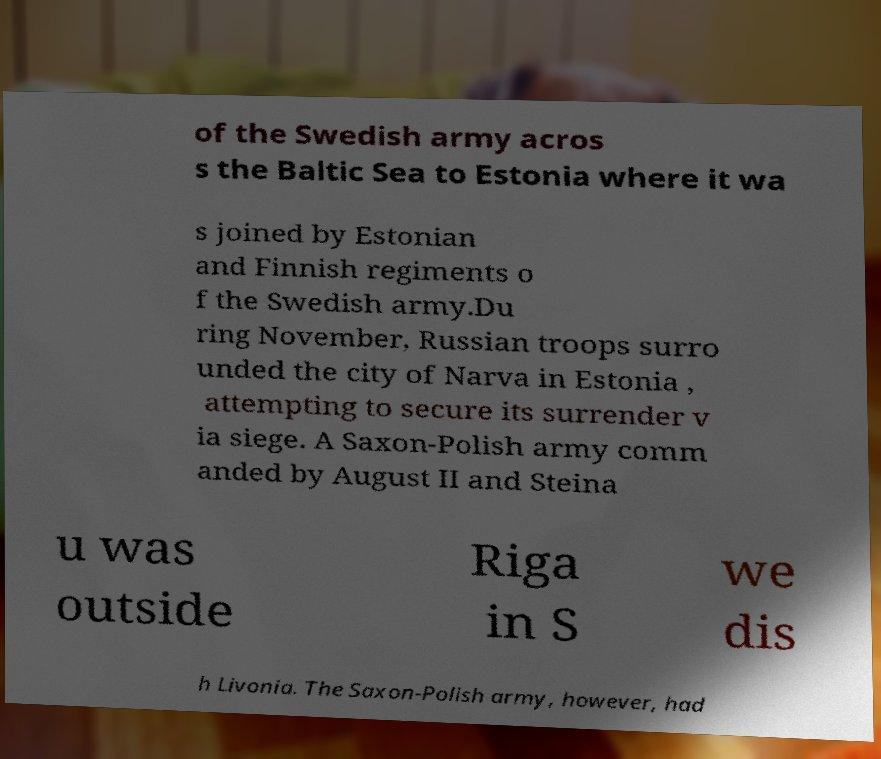I need the written content from this picture converted into text. Can you do that? of the Swedish army acros s the Baltic Sea to Estonia where it wa s joined by Estonian and Finnish regiments o f the Swedish army.Du ring November, Russian troops surro unded the city of Narva in Estonia , attempting to secure its surrender v ia siege. A Saxon-Polish army comm anded by August II and Steina u was outside Riga in S we dis h Livonia. The Saxon-Polish army, however, had 